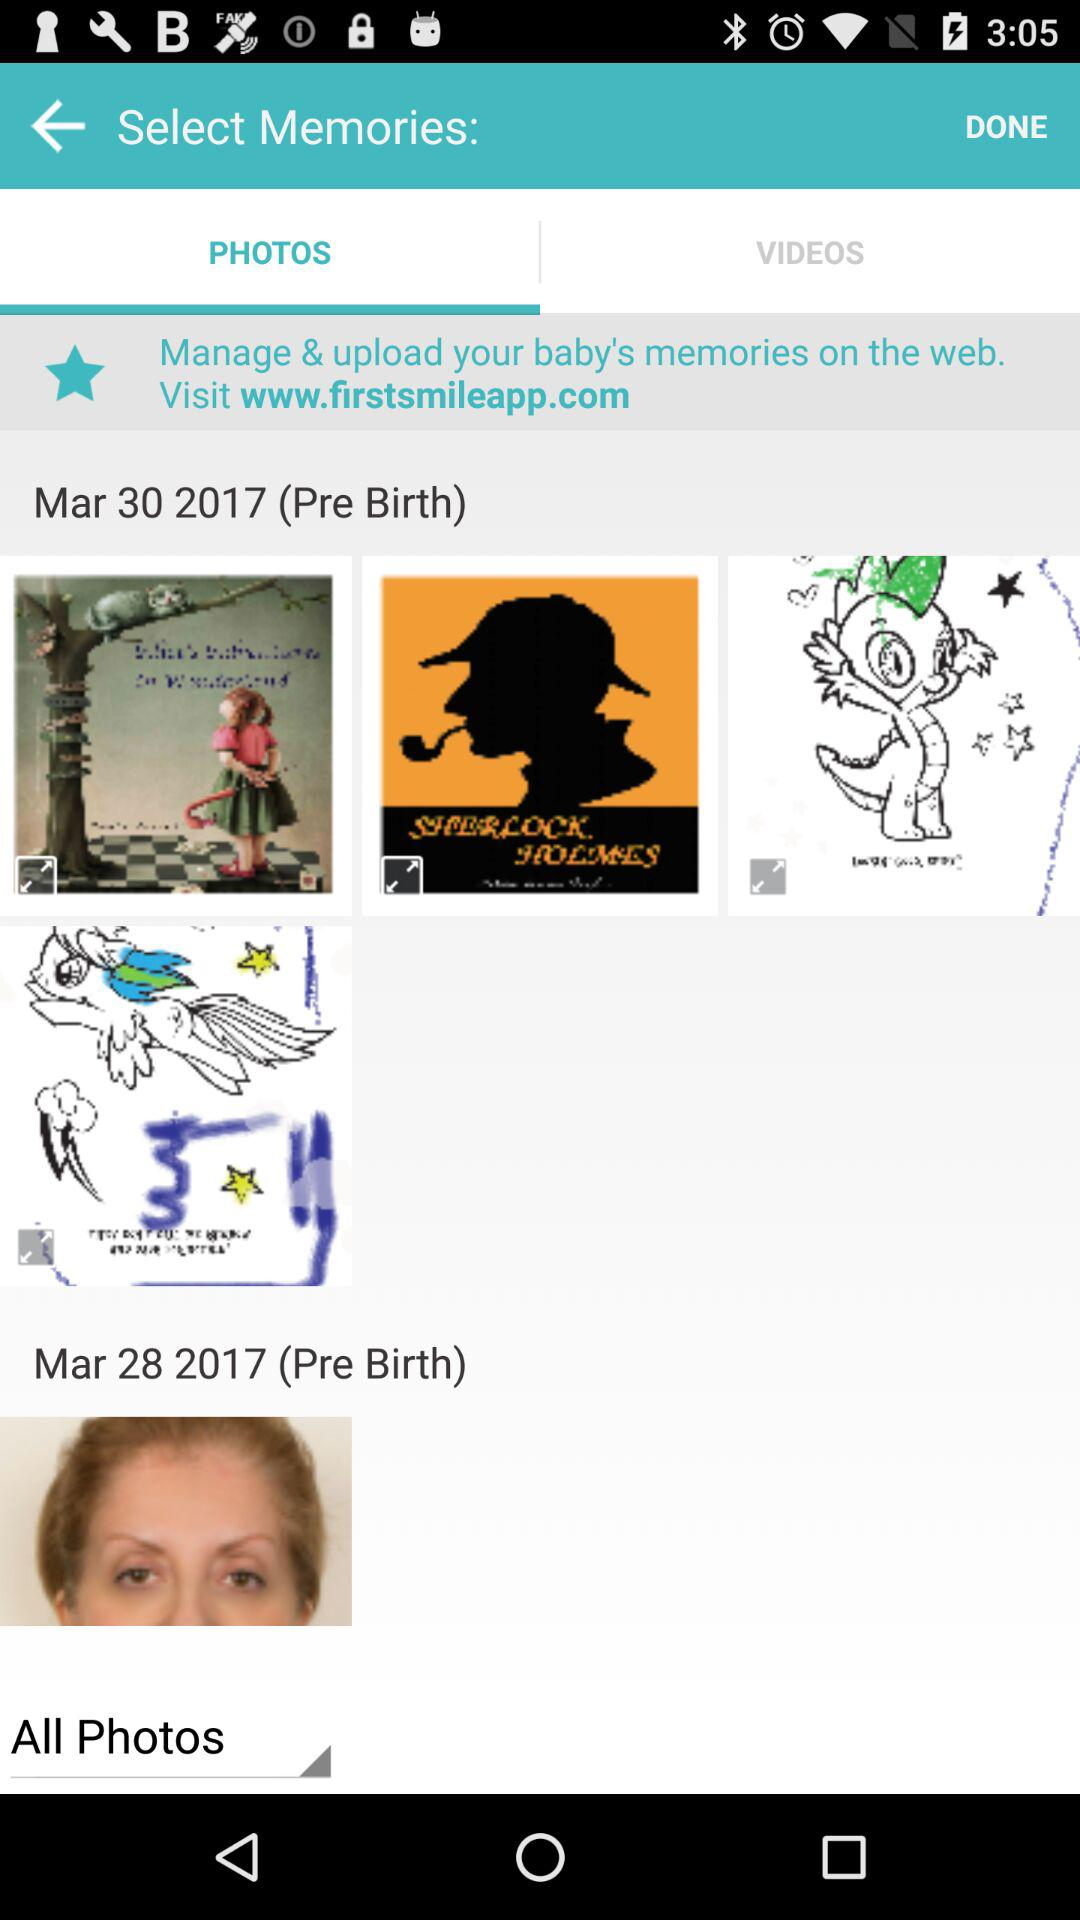For which dates are the photos shown? The photos are shown for the dates March 30, 2017 and March 28, 2017. 